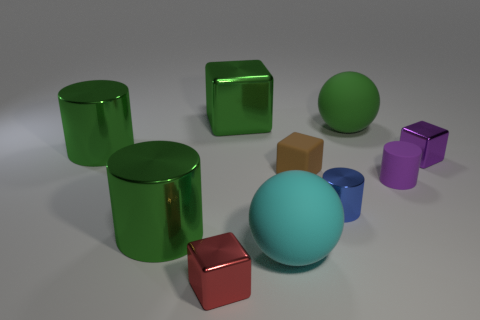Is there a large metallic object that has the same color as the large block?
Offer a terse response. Yes. Do the red metal object and the purple cube have the same size?
Offer a very short reply. Yes. There is a green metal cylinder that is in front of the metal cube on the right side of the large green ball; what size is it?
Offer a very short reply. Large. There is a cube that is both in front of the purple metal thing and behind the tiny red cube; how big is it?
Your response must be concise. Small. What number of rubber things have the same size as the green metal block?
Give a very brief answer. 2. What number of metallic objects are either green cylinders or large cyan balls?
Offer a terse response. 2. The metal block that is the same color as the rubber cylinder is what size?
Keep it short and to the point. Small. The green cylinder behind the big metallic cylinder that is in front of the small purple rubber cylinder is made of what material?
Ensure brevity in your answer.  Metal. What number of things are either large green metal cylinders or metallic things behind the small red thing?
Your response must be concise. 5. What is the size of the cyan ball that is the same material as the tiny brown thing?
Offer a terse response. Large. 